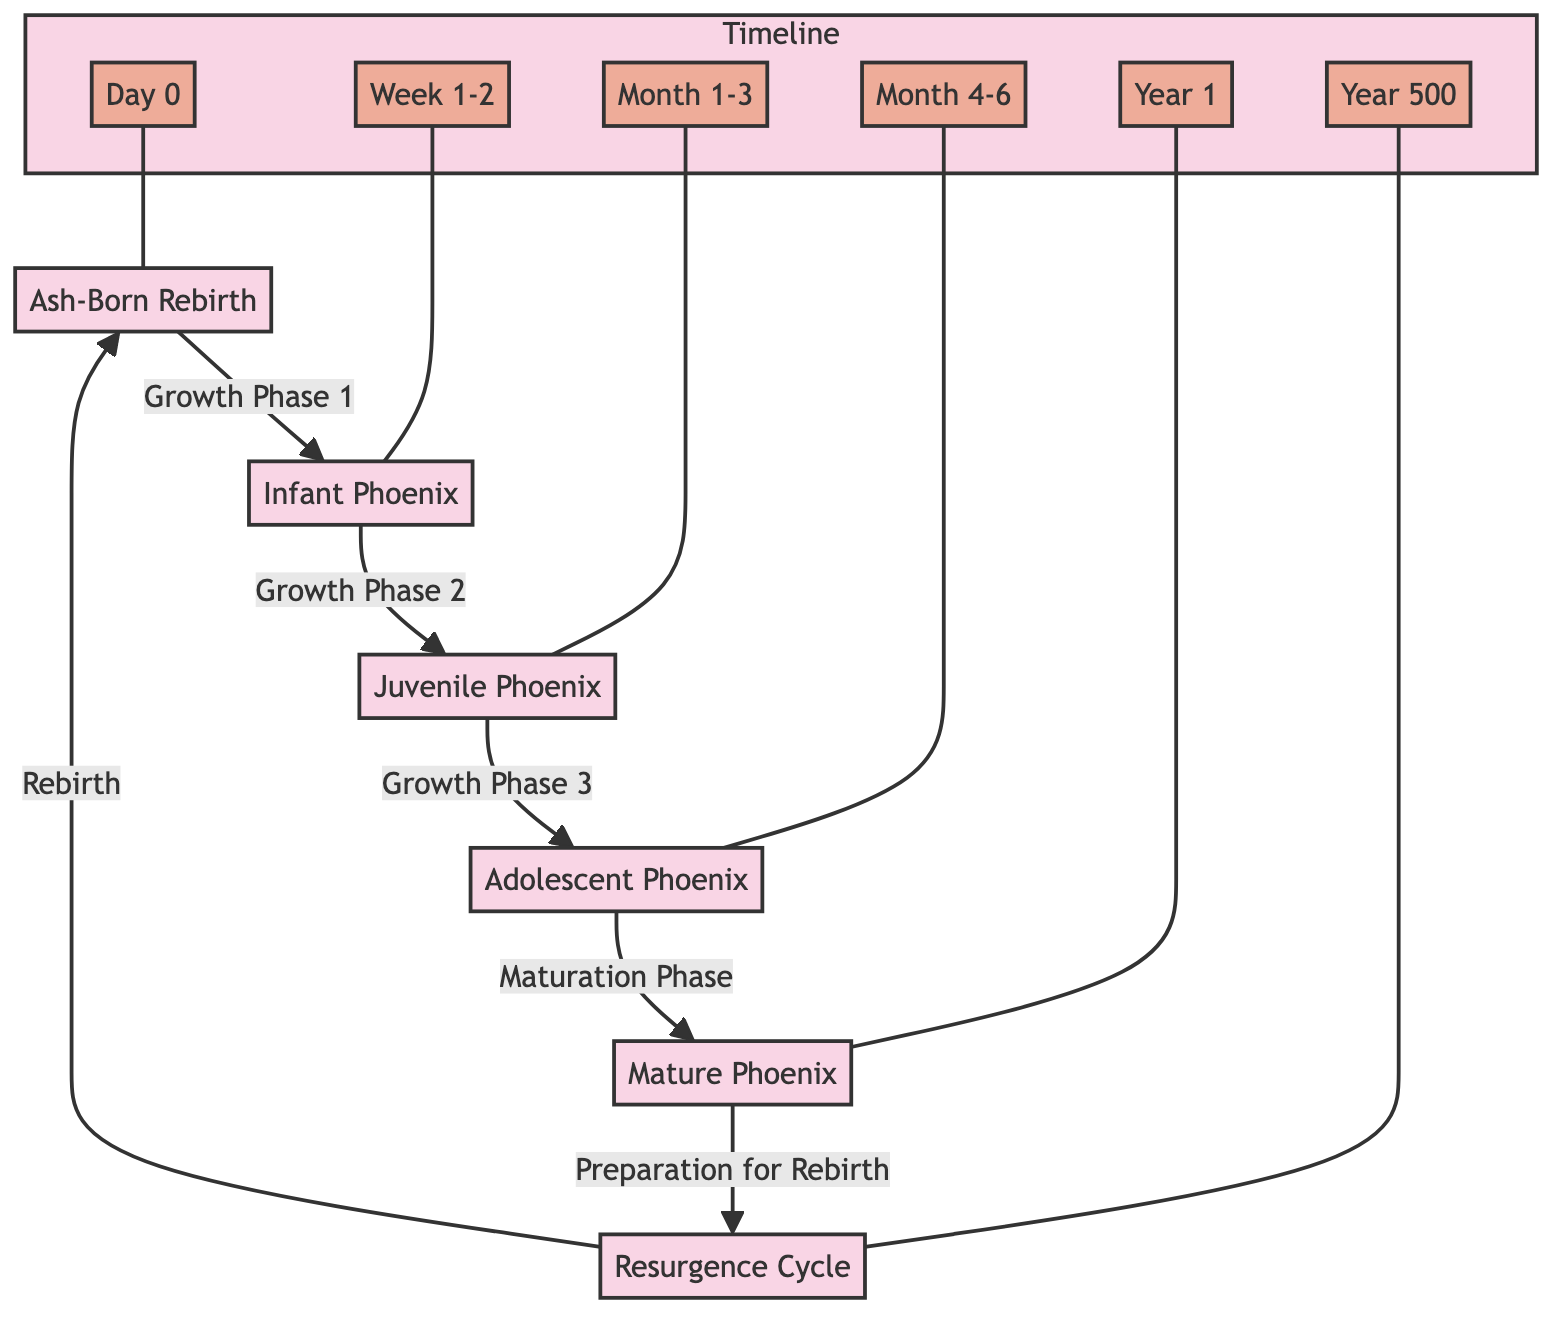What is the first stage of the Phoenix life cycle? The diagram starts with "Ash-Born Rebirth," which is represented as the initial stage in the lifecycle.
Answer: Ash-Born Rebirth How many main growth phases are depicted before reaching a mature Phoenix? The diagram shows three distinct growth phases leading to the mature Phoenix, which can be identified by the colored connections from one node to another.
Answer: 3 What is the last stage of the Phoenix lifecycle before it rejuvenates? The final stage represented in the diagram before returning to the "Ash-Born Rebirth" is the "Preparation for Rebirth," as indicated in the flow from the mature Phoenix.
Answer: Preparation for Rebirth Which growth phase occurs after the juvenile Phoenix? The diagram indicates that after the juvenile Phoenix, the next growth phase is the adolescent Phoenix, which is directly connected in the lifecycle progression.
Answer: Adolescent Phoenix How long does it take for a Phoenix to reach its mature stage after the ash-born rebirth? According to the timeline markers, the diagram indicates that the transition to the mature stage occurs around Year 1, showing the duration from the initial stage to maturity.
Answer: Year 1 What is the average lifespan of a Phoenix before it undergoes the resurgence cycle? The diagram depicts a lifespan marker of Year 500, which indicates the average lifespan before it repeats the cycle of rebirth and resurgence.
Answer: Year 500 What are the color deviations indicating for each life stage? Each color represents distinct stages of growth, which helps visually differentiate between the life cycle phases, with specific colors assigned to each phase as outlined in the diagram's styles.
Answer: Unique color codes for each stage Which stage follows the infant Phoenix in its lifecycle? The flowchart clearly indicates that the juvenile Phoenix follows the infant stage, as identified by the direct connection arrow from the infant node to the juvenile node.
Answer: Juvenile Phoenix What visual cues mark the transition between phases in the diagram? The diagram uses colored arrows and distinct node styles to mark transitions, with each growth phase and maturation phase represented uniquely.
Answer: Colored arrows and node styles 